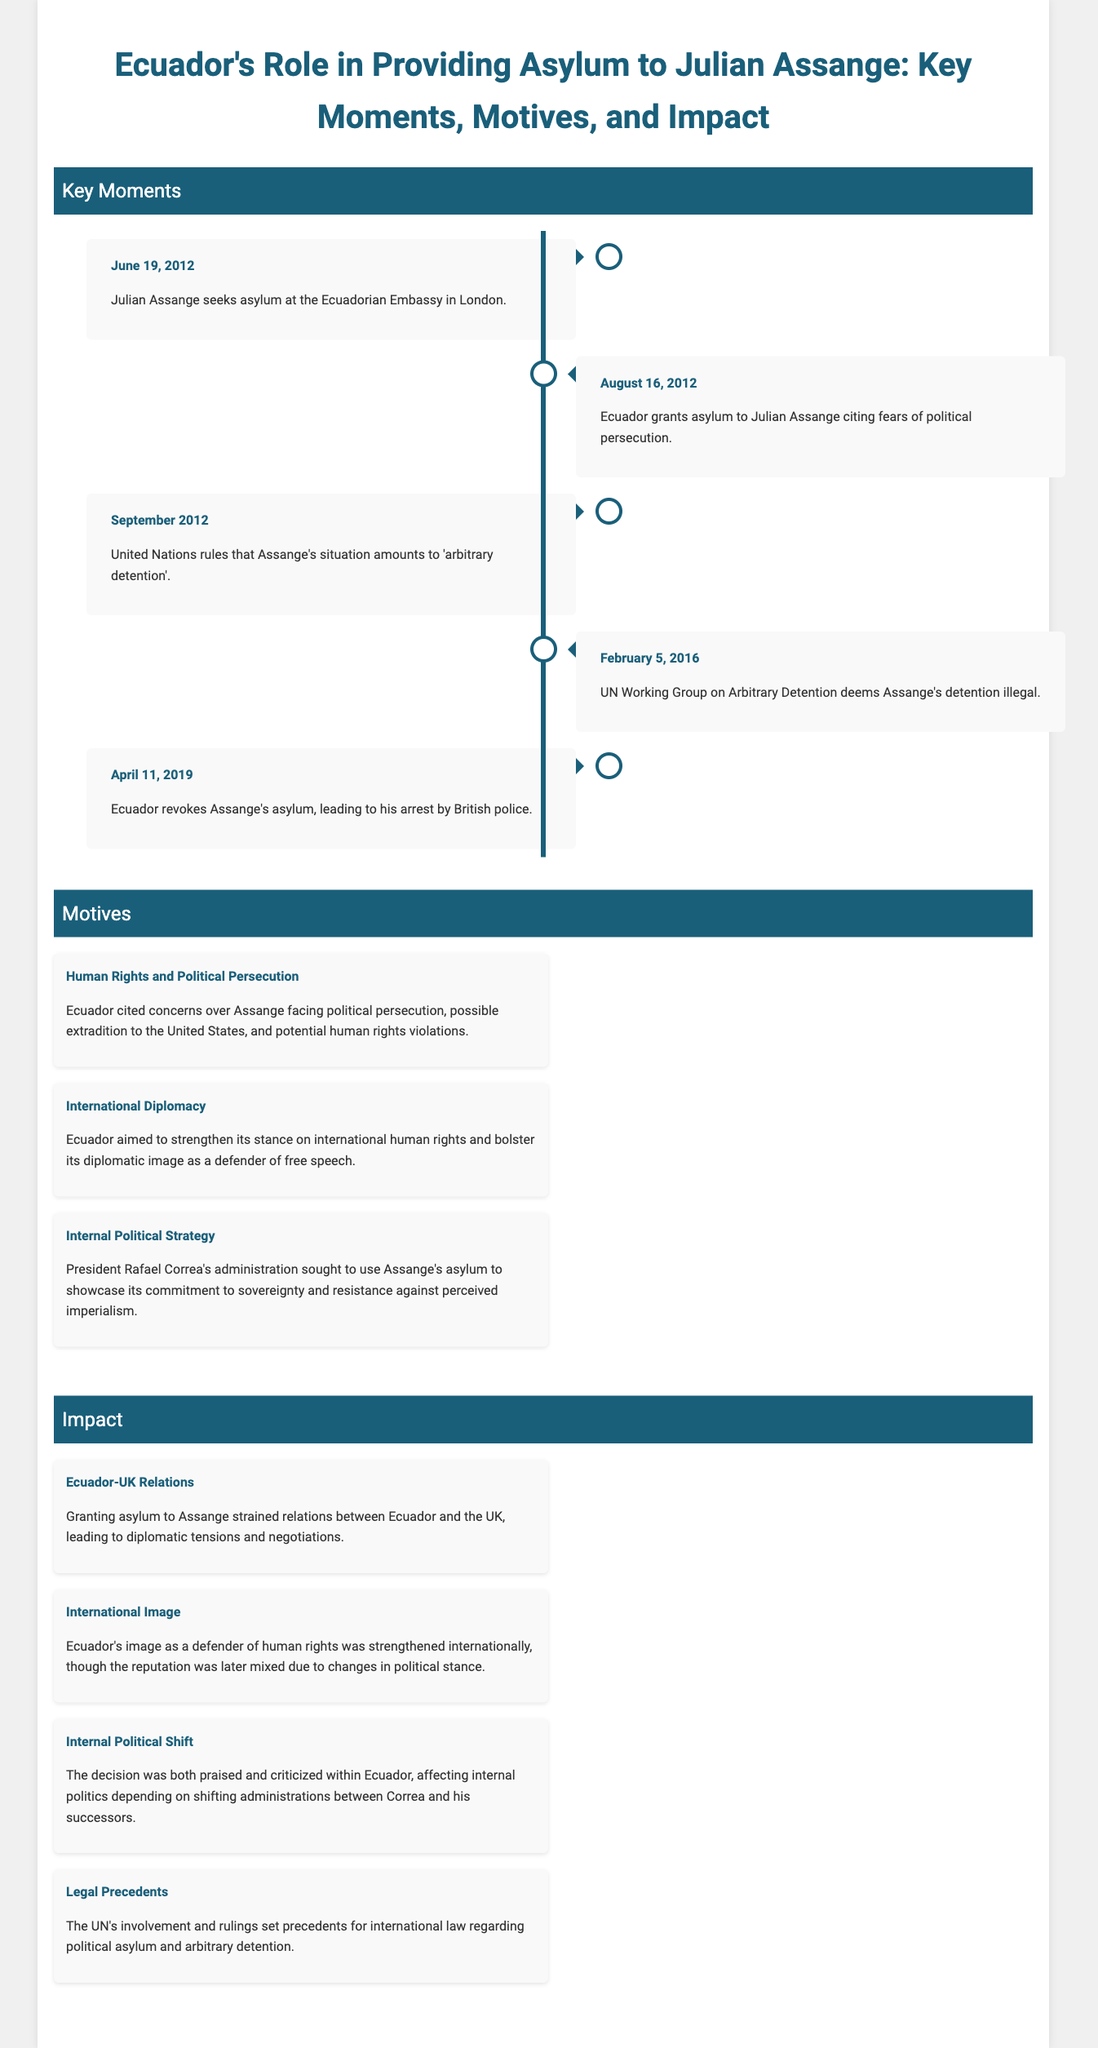What date did Julian Assange seek asylum? The document states that Julian Assange sought asylum on June 19, 2012.
Answer: June 19, 2012 When did Ecuador grant asylum to Julian Assange? According to the timeline, Ecuador granted asylum on August 16, 2012.
Answer: August 16, 2012 What was one of the motives for granting asylum? The document lists several motives, one of which is "Human Rights and Political Persecution."
Answer: Human Rights and Political Persecution What impact did granting asylum have on Ecuador-UK relations? The document notes that granting asylum strained relations between Ecuador and the UK.
Answer: Strained relations Which UN ruling is mentioned regarding Assange's situation? The document states that the United Nations ruled that Assange's situation amounted to 'arbitrary detention'.
Answer: Arbitrary detention What was one internal political strategy related to Assange's asylum? The document mentions showcasing commitment to sovereignty as an internal political strategy.
Answer: Commitment to sovereignty How did Ecuador's international image change after granting asylum? According to the document, Ecuador's image as a defender of human rights was strengthened internationally.
Answer: Strengthened internationally What was one legal precedent set by the UN's involvement? The document mentions that the UN's involvement set precedents for political asylum and arbitrary detention.
Answer: Political asylum and arbitrary detention 